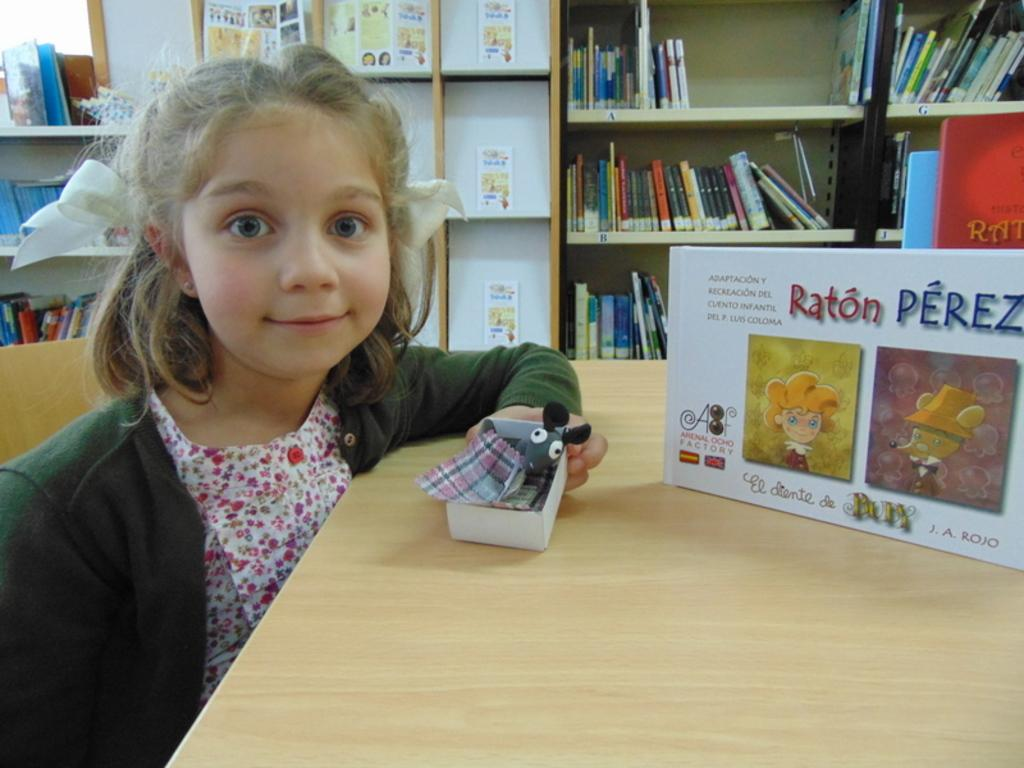<image>
Render a clear and concise summary of the photo. A young girl sitting at a desk in front of a copy of Raton Perez by J.A. Rojo 